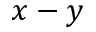Convert formula to latex. <formula><loc_0><loc_0><loc_500><loc_500>x - y</formula> 